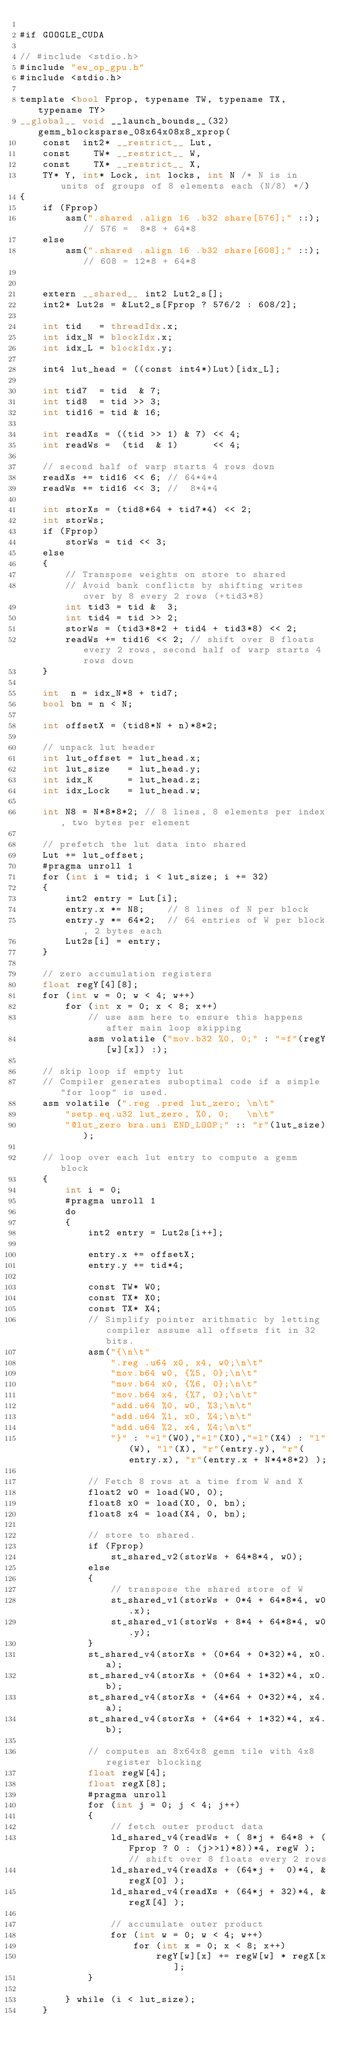Convert code to text. <code><loc_0><loc_0><loc_500><loc_500><_Cuda_>
#if GOOGLE_CUDA

// #include <stdio.h>
#include "ew_op_gpu.h"
#include <stdio.h>

template <bool Fprop, typename TW, typename TX, typename TY>
__global__ void __launch_bounds__(32) gemm_blocksparse_08x64x08x8_xprop(
    const  int2* __restrict__ Lut,
    const    TW* __restrict__ W,
    const    TX* __restrict__ X,
    TY* Y, int* Lock, int locks, int N /* N is in units of groups of 8 elements each (N/8) */)
{
    if (Fprop)
        asm(".shared .align 16 .b32 share[576];" ::); // 576 =  8*8 + 64*8
    else
        asm(".shared .align 16 .b32 share[608];" ::); // 608 = 12*8 + 64*8


    extern __shared__ int2 Lut2_s[];
    int2* Lut2s = &Lut2_s[Fprop ? 576/2 : 608/2];

    int tid   = threadIdx.x;
    int idx_N = blockIdx.x;
    int idx_L = blockIdx.y;

    int4 lut_head = ((const int4*)Lut)[idx_L];

    int tid7  = tid  & 7;
    int tid8  = tid >> 3;
    int tid16 = tid & 16;

    int readXs = ((tid >> 1) & 7) << 4;
    int readWs =  (tid  & 1)      << 4;

    // second half of warp starts 4 rows down
    readXs += tid16 << 6; // 64*4*4
    readWs += tid16 << 3; //  8*4*4

    int storXs = (tid8*64 + tid7*4) << 2;
    int storWs;
    if (Fprop)
        storWs = tid << 3;
    else
    {
        // Transpose weights on store to shared
        // Avoid bank conflicts by shifting writes over by 8 every 2 rows (+tid3*8)
        int tid3 = tid &  3;
        int tid4 = tid >> 2;
        storWs = (tid3*8*2 + tid4 + tid3*8) << 2;
        readWs += tid16 << 2; // shift over 8 floats every 2 rows, second half of warp starts 4 rows down
    }

    int  n = idx_N*8 + tid7;
    bool bn = n < N;

    int offsetX = (tid8*N + n)*8*2;

    // unpack lut header
    int lut_offset = lut_head.x;
    int lut_size   = lut_head.y;
    int idx_K      = lut_head.z;
    int idx_Lock   = lut_head.w;

    int N8 = N*8*8*2; // 8 lines, 8 elements per index, two bytes per element

    // prefetch the lut data into shared
    Lut += lut_offset;
    #pragma unroll 1
    for (int i = tid; i < lut_size; i += 32)
    {
        int2 entry = Lut[i];
        entry.x *= N8;    // 8 lines of N per block
        entry.y *= 64*2;  // 64 entries of W per block, 2 bytes each
        Lut2s[i] = entry;
    }

    // zero accumulation registers
    float regY[4][8];
    for (int w = 0; w < 4; w++)
        for (int x = 0; x < 8; x++)
            // use asm here to ensure this happens after main loop skipping
            asm volatile ("mov.b32 %0, 0;" : "=f"(regY[w][x]) :);

    // skip loop if empty lut
    // Compiler generates suboptimal code if a simple "for loop" is used.
    asm volatile (".reg .pred lut_zero; \n\t"
        "setp.eq.u32 lut_zero, %0, 0;   \n\t"
        "@lut_zero bra.uni END_LOOP;" :: "r"(lut_size));

    // loop over each lut entry to compute a gemm block
    {
        int i = 0;
        #pragma unroll 1
        do
        {
            int2 entry = Lut2s[i++];

            entry.x += offsetX;
            entry.y += tid*4;

            const TW* W0;
            const TX* X0;
            const TX* X4;
            // Simplify pointer arithmatic by letting compiler assume all offsets fit in 32 bits.
            asm("{\n\t"
                ".reg .u64 x0, x4, w0;\n\t"
                "mov.b64 w0, {%5, 0};\n\t"
                "mov.b64 x0, {%6, 0};\n\t"
                "mov.b64 x4, {%7, 0};\n\t"
                "add.u64 %0, w0, %3;\n\t"
                "add.u64 %1, x0, %4;\n\t"
                "add.u64 %2, x4, %4;\n\t"
                "}" : "=l"(W0),"=l"(X0),"=l"(X4) : "l"(W), "l"(X), "r"(entry.y), "r"(entry.x), "r"(entry.x + N*4*8*2) );

            // Fetch 8 rows at a time from W and X
            float2 w0 = load(W0, 0);
            float8 x0 = load(X0, 0, bn);
            float8 x4 = load(X4, 0, bn);

            // store to shared.
            if (Fprop)
                st_shared_v2(storWs + 64*8*4, w0);
            else
            {
                // transpose the shared store of W
                st_shared_v1(storWs + 0*4 + 64*8*4, w0.x);
                st_shared_v1(storWs + 8*4 + 64*8*4, w0.y);
            }
            st_shared_v4(storXs + (0*64 + 0*32)*4, x0.a);
            st_shared_v4(storXs + (0*64 + 1*32)*4, x0.b);
            st_shared_v4(storXs + (4*64 + 0*32)*4, x4.a);
            st_shared_v4(storXs + (4*64 + 1*32)*4, x4.b);

            // computes an 8x64x8 gemm tile with 4x8 register blocking
            float regW[4];
            float regX[8];
            #pragma unroll
            for (int j = 0; j < 4; j++)
            {
                // fetch outer product data
                ld_shared_v4(readWs + ( 8*j + 64*8 + (Fprop ? 0 : (j>>1)*8))*4, regW ); // shift over 8 floats every 2 rows
                ld_shared_v4(readXs + (64*j +  0)*4, &regX[0] );
                ld_shared_v4(readXs + (64*j + 32)*4, &regX[4] );

                // accumulate outer product
                for (int w = 0; w < 4; w++)
                    for (int x = 0; x < 8; x++)
                        regY[w][x] += regW[w] * regX[x];
            }

        } while (i < lut_size);
    }</code> 